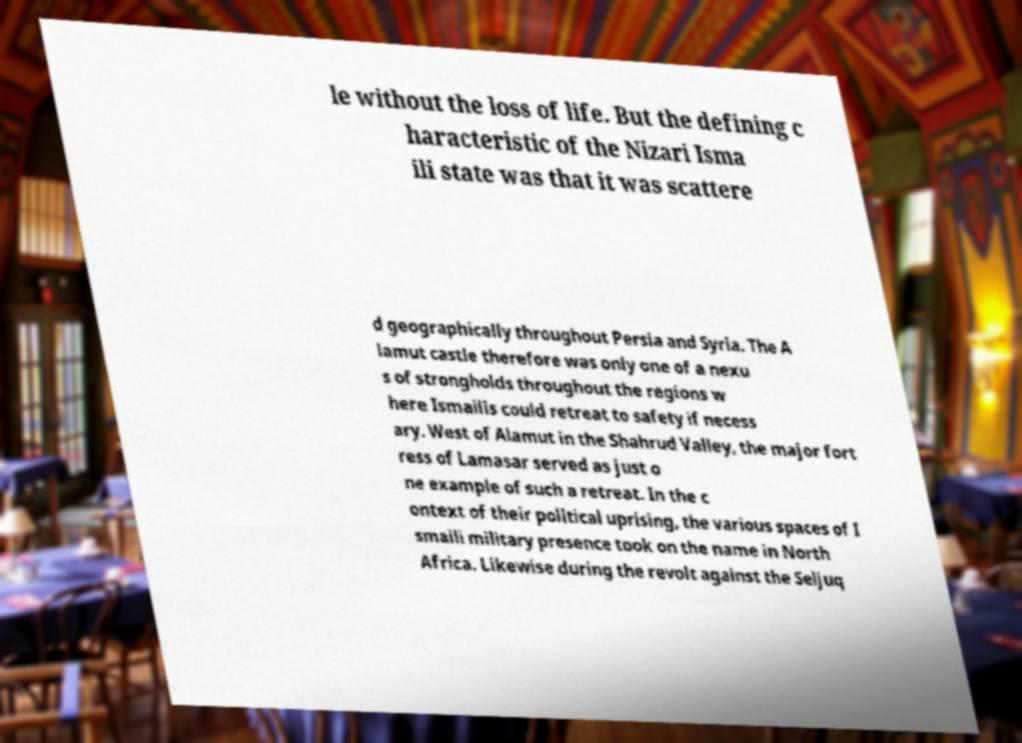Can you accurately transcribe the text from the provided image for me? le without the loss of life. But the defining c haracteristic of the Nizari Isma ili state was that it was scattere d geographically throughout Persia and Syria. The A lamut castle therefore was only one of a nexu s of strongholds throughout the regions w here Ismailis could retreat to safety if necess ary. West of Alamut in the Shahrud Valley, the major fort ress of Lamasar served as just o ne example of such a retreat. In the c ontext of their political uprising, the various spaces of I smaili military presence took on the name in North Africa. Likewise during the revolt against the Seljuq 